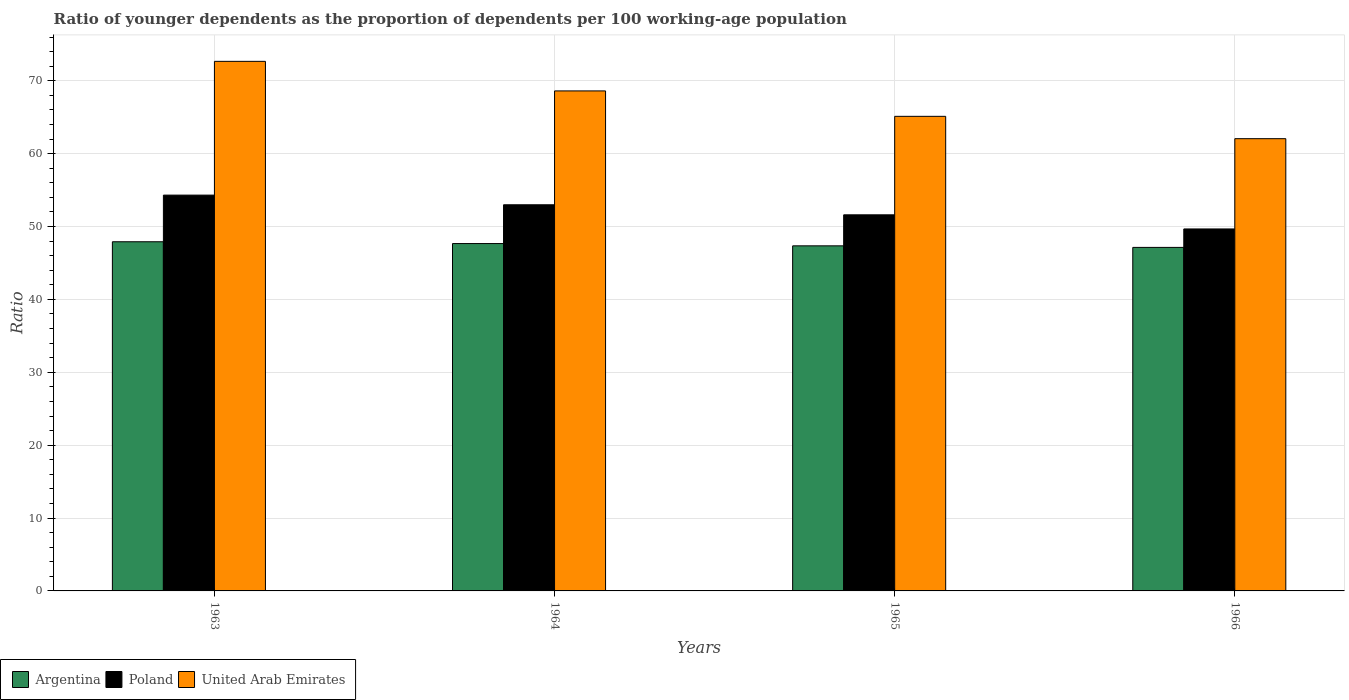How many different coloured bars are there?
Your answer should be very brief. 3. How many groups of bars are there?
Your answer should be compact. 4. Are the number of bars on each tick of the X-axis equal?
Offer a terse response. Yes. What is the label of the 3rd group of bars from the left?
Offer a very short reply. 1965. In how many cases, is the number of bars for a given year not equal to the number of legend labels?
Keep it short and to the point. 0. What is the age dependency ratio(young) in Poland in 1965?
Your answer should be compact. 51.6. Across all years, what is the maximum age dependency ratio(young) in Argentina?
Make the answer very short. 47.91. Across all years, what is the minimum age dependency ratio(young) in United Arab Emirates?
Ensure brevity in your answer.  62.05. In which year was the age dependency ratio(young) in Argentina maximum?
Provide a succinct answer. 1963. In which year was the age dependency ratio(young) in Argentina minimum?
Provide a short and direct response. 1966. What is the total age dependency ratio(young) in United Arab Emirates in the graph?
Your response must be concise. 268.43. What is the difference between the age dependency ratio(young) in Poland in 1964 and that in 1966?
Offer a terse response. 3.32. What is the difference between the age dependency ratio(young) in Argentina in 1965 and the age dependency ratio(young) in Poland in 1964?
Keep it short and to the point. -5.63. What is the average age dependency ratio(young) in Argentina per year?
Your answer should be very brief. 47.51. In the year 1963, what is the difference between the age dependency ratio(young) in United Arab Emirates and age dependency ratio(young) in Argentina?
Your answer should be very brief. 24.75. What is the ratio of the age dependency ratio(young) in Argentina in 1965 to that in 1966?
Your response must be concise. 1. What is the difference between the highest and the second highest age dependency ratio(young) in Poland?
Offer a terse response. 1.32. What is the difference between the highest and the lowest age dependency ratio(young) in Poland?
Give a very brief answer. 4.64. Is the sum of the age dependency ratio(young) in Poland in 1964 and 1965 greater than the maximum age dependency ratio(young) in United Arab Emirates across all years?
Your response must be concise. Yes. What does the 1st bar from the left in 1965 represents?
Ensure brevity in your answer.  Argentina. How many bars are there?
Provide a succinct answer. 12. How many years are there in the graph?
Ensure brevity in your answer.  4. Are the values on the major ticks of Y-axis written in scientific E-notation?
Offer a very short reply. No. Does the graph contain any zero values?
Provide a succinct answer. No. Where does the legend appear in the graph?
Provide a succinct answer. Bottom left. How many legend labels are there?
Ensure brevity in your answer.  3. How are the legend labels stacked?
Give a very brief answer. Horizontal. What is the title of the graph?
Ensure brevity in your answer.  Ratio of younger dependents as the proportion of dependents per 100 working-age population. What is the label or title of the Y-axis?
Offer a terse response. Ratio. What is the Ratio in Argentina in 1963?
Provide a short and direct response. 47.91. What is the Ratio of Poland in 1963?
Offer a terse response. 54.31. What is the Ratio of United Arab Emirates in 1963?
Ensure brevity in your answer.  72.66. What is the Ratio of Argentina in 1964?
Your answer should be very brief. 47.66. What is the Ratio in Poland in 1964?
Your answer should be very brief. 52.98. What is the Ratio in United Arab Emirates in 1964?
Your answer should be very brief. 68.6. What is the Ratio of Argentina in 1965?
Provide a succinct answer. 47.35. What is the Ratio of Poland in 1965?
Keep it short and to the point. 51.6. What is the Ratio in United Arab Emirates in 1965?
Offer a very short reply. 65.12. What is the Ratio of Argentina in 1966?
Provide a short and direct response. 47.13. What is the Ratio in Poland in 1966?
Your answer should be very brief. 49.67. What is the Ratio in United Arab Emirates in 1966?
Offer a very short reply. 62.05. Across all years, what is the maximum Ratio of Argentina?
Provide a short and direct response. 47.91. Across all years, what is the maximum Ratio in Poland?
Give a very brief answer. 54.31. Across all years, what is the maximum Ratio of United Arab Emirates?
Offer a terse response. 72.66. Across all years, what is the minimum Ratio in Argentina?
Offer a terse response. 47.13. Across all years, what is the minimum Ratio in Poland?
Provide a short and direct response. 49.67. Across all years, what is the minimum Ratio of United Arab Emirates?
Make the answer very short. 62.05. What is the total Ratio in Argentina in the graph?
Give a very brief answer. 190.05. What is the total Ratio in Poland in the graph?
Keep it short and to the point. 208.56. What is the total Ratio in United Arab Emirates in the graph?
Offer a very short reply. 268.43. What is the difference between the Ratio of Argentina in 1963 and that in 1964?
Ensure brevity in your answer.  0.25. What is the difference between the Ratio of Poland in 1963 and that in 1964?
Provide a succinct answer. 1.32. What is the difference between the Ratio of United Arab Emirates in 1963 and that in 1964?
Your answer should be compact. 4.06. What is the difference between the Ratio of Argentina in 1963 and that in 1965?
Provide a succinct answer. 0.56. What is the difference between the Ratio of Poland in 1963 and that in 1965?
Provide a succinct answer. 2.7. What is the difference between the Ratio in United Arab Emirates in 1963 and that in 1965?
Make the answer very short. 7.55. What is the difference between the Ratio in Argentina in 1963 and that in 1966?
Make the answer very short. 0.77. What is the difference between the Ratio of Poland in 1963 and that in 1966?
Your answer should be very brief. 4.64. What is the difference between the Ratio of United Arab Emirates in 1963 and that in 1966?
Offer a terse response. 10.61. What is the difference between the Ratio in Argentina in 1964 and that in 1965?
Give a very brief answer. 0.31. What is the difference between the Ratio of Poland in 1964 and that in 1965?
Offer a very short reply. 1.38. What is the difference between the Ratio in United Arab Emirates in 1964 and that in 1965?
Keep it short and to the point. 3.49. What is the difference between the Ratio of Argentina in 1964 and that in 1966?
Provide a short and direct response. 0.53. What is the difference between the Ratio in Poland in 1964 and that in 1966?
Your answer should be compact. 3.32. What is the difference between the Ratio in United Arab Emirates in 1964 and that in 1966?
Offer a terse response. 6.55. What is the difference between the Ratio of Argentina in 1965 and that in 1966?
Give a very brief answer. 0.21. What is the difference between the Ratio in Poland in 1965 and that in 1966?
Your response must be concise. 1.94. What is the difference between the Ratio of United Arab Emirates in 1965 and that in 1966?
Your response must be concise. 3.06. What is the difference between the Ratio of Argentina in 1963 and the Ratio of Poland in 1964?
Keep it short and to the point. -5.07. What is the difference between the Ratio of Argentina in 1963 and the Ratio of United Arab Emirates in 1964?
Make the answer very short. -20.7. What is the difference between the Ratio of Poland in 1963 and the Ratio of United Arab Emirates in 1964?
Provide a short and direct response. -14.3. What is the difference between the Ratio of Argentina in 1963 and the Ratio of Poland in 1965?
Keep it short and to the point. -3.69. What is the difference between the Ratio in Argentina in 1963 and the Ratio in United Arab Emirates in 1965?
Your response must be concise. -17.21. What is the difference between the Ratio of Poland in 1963 and the Ratio of United Arab Emirates in 1965?
Provide a succinct answer. -10.81. What is the difference between the Ratio of Argentina in 1963 and the Ratio of Poland in 1966?
Provide a short and direct response. -1.76. What is the difference between the Ratio in Argentina in 1963 and the Ratio in United Arab Emirates in 1966?
Give a very brief answer. -14.14. What is the difference between the Ratio of Poland in 1963 and the Ratio of United Arab Emirates in 1966?
Provide a succinct answer. -7.75. What is the difference between the Ratio in Argentina in 1964 and the Ratio in Poland in 1965?
Provide a short and direct response. -3.94. What is the difference between the Ratio in Argentina in 1964 and the Ratio in United Arab Emirates in 1965?
Offer a terse response. -17.45. What is the difference between the Ratio in Poland in 1964 and the Ratio in United Arab Emirates in 1965?
Ensure brevity in your answer.  -12.13. What is the difference between the Ratio of Argentina in 1964 and the Ratio of Poland in 1966?
Provide a short and direct response. -2. What is the difference between the Ratio of Argentina in 1964 and the Ratio of United Arab Emirates in 1966?
Your answer should be very brief. -14.39. What is the difference between the Ratio in Poland in 1964 and the Ratio in United Arab Emirates in 1966?
Keep it short and to the point. -9.07. What is the difference between the Ratio of Argentina in 1965 and the Ratio of Poland in 1966?
Provide a succinct answer. -2.32. What is the difference between the Ratio of Argentina in 1965 and the Ratio of United Arab Emirates in 1966?
Your answer should be very brief. -14.7. What is the difference between the Ratio in Poland in 1965 and the Ratio in United Arab Emirates in 1966?
Make the answer very short. -10.45. What is the average Ratio of Argentina per year?
Keep it short and to the point. 47.51. What is the average Ratio in Poland per year?
Offer a terse response. 52.14. What is the average Ratio in United Arab Emirates per year?
Your answer should be very brief. 67.11. In the year 1963, what is the difference between the Ratio in Argentina and Ratio in Poland?
Your response must be concise. -6.4. In the year 1963, what is the difference between the Ratio in Argentina and Ratio in United Arab Emirates?
Make the answer very short. -24.75. In the year 1963, what is the difference between the Ratio of Poland and Ratio of United Arab Emirates?
Keep it short and to the point. -18.35. In the year 1964, what is the difference between the Ratio in Argentina and Ratio in Poland?
Provide a short and direct response. -5.32. In the year 1964, what is the difference between the Ratio in Argentina and Ratio in United Arab Emirates?
Make the answer very short. -20.94. In the year 1964, what is the difference between the Ratio of Poland and Ratio of United Arab Emirates?
Make the answer very short. -15.62. In the year 1965, what is the difference between the Ratio in Argentina and Ratio in Poland?
Your answer should be very brief. -4.26. In the year 1965, what is the difference between the Ratio of Argentina and Ratio of United Arab Emirates?
Offer a very short reply. -17.77. In the year 1965, what is the difference between the Ratio of Poland and Ratio of United Arab Emirates?
Give a very brief answer. -13.51. In the year 1966, what is the difference between the Ratio in Argentina and Ratio in Poland?
Ensure brevity in your answer.  -2.53. In the year 1966, what is the difference between the Ratio of Argentina and Ratio of United Arab Emirates?
Make the answer very short. -14.92. In the year 1966, what is the difference between the Ratio of Poland and Ratio of United Arab Emirates?
Make the answer very short. -12.39. What is the ratio of the Ratio of Poland in 1963 to that in 1964?
Your answer should be very brief. 1.02. What is the ratio of the Ratio in United Arab Emirates in 1963 to that in 1964?
Your response must be concise. 1.06. What is the ratio of the Ratio in Argentina in 1963 to that in 1965?
Provide a short and direct response. 1.01. What is the ratio of the Ratio in Poland in 1963 to that in 1965?
Your answer should be very brief. 1.05. What is the ratio of the Ratio in United Arab Emirates in 1963 to that in 1965?
Offer a terse response. 1.12. What is the ratio of the Ratio in Argentina in 1963 to that in 1966?
Provide a succinct answer. 1.02. What is the ratio of the Ratio of Poland in 1963 to that in 1966?
Provide a succinct answer. 1.09. What is the ratio of the Ratio in United Arab Emirates in 1963 to that in 1966?
Your response must be concise. 1.17. What is the ratio of the Ratio of Argentina in 1964 to that in 1965?
Provide a short and direct response. 1.01. What is the ratio of the Ratio in Poland in 1964 to that in 1965?
Your response must be concise. 1.03. What is the ratio of the Ratio of United Arab Emirates in 1964 to that in 1965?
Offer a terse response. 1.05. What is the ratio of the Ratio in Argentina in 1964 to that in 1966?
Your answer should be very brief. 1.01. What is the ratio of the Ratio of Poland in 1964 to that in 1966?
Offer a terse response. 1.07. What is the ratio of the Ratio in United Arab Emirates in 1964 to that in 1966?
Your answer should be compact. 1.11. What is the ratio of the Ratio of Argentina in 1965 to that in 1966?
Provide a short and direct response. 1. What is the ratio of the Ratio of Poland in 1965 to that in 1966?
Provide a succinct answer. 1.04. What is the ratio of the Ratio of United Arab Emirates in 1965 to that in 1966?
Your answer should be compact. 1.05. What is the difference between the highest and the second highest Ratio of Argentina?
Keep it short and to the point. 0.25. What is the difference between the highest and the second highest Ratio of Poland?
Offer a very short reply. 1.32. What is the difference between the highest and the second highest Ratio in United Arab Emirates?
Your response must be concise. 4.06. What is the difference between the highest and the lowest Ratio in Argentina?
Give a very brief answer. 0.77. What is the difference between the highest and the lowest Ratio of Poland?
Offer a very short reply. 4.64. What is the difference between the highest and the lowest Ratio of United Arab Emirates?
Provide a short and direct response. 10.61. 